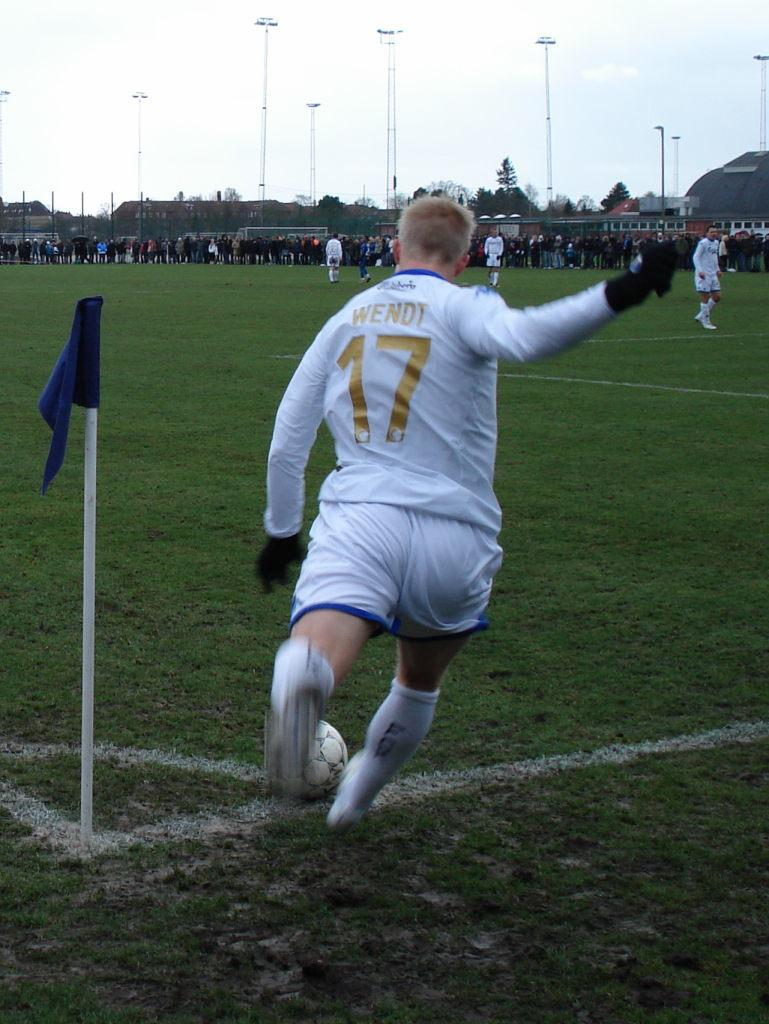How many people are in the image? There is a group of people in the image. What are the people in the image doing? The people are standing, and one person is kicking a ball. What can be seen in the background of the image? There are poles and the sky visible in the background of the image. What is visible at the bottom of the image? The ground is visible in the image. Are there any giants visible in the image? No, there are no giants present in the image. What type of structure can be seen in the background of the image? There is no structure visible in the background of the image; only poles and the sky are present. 